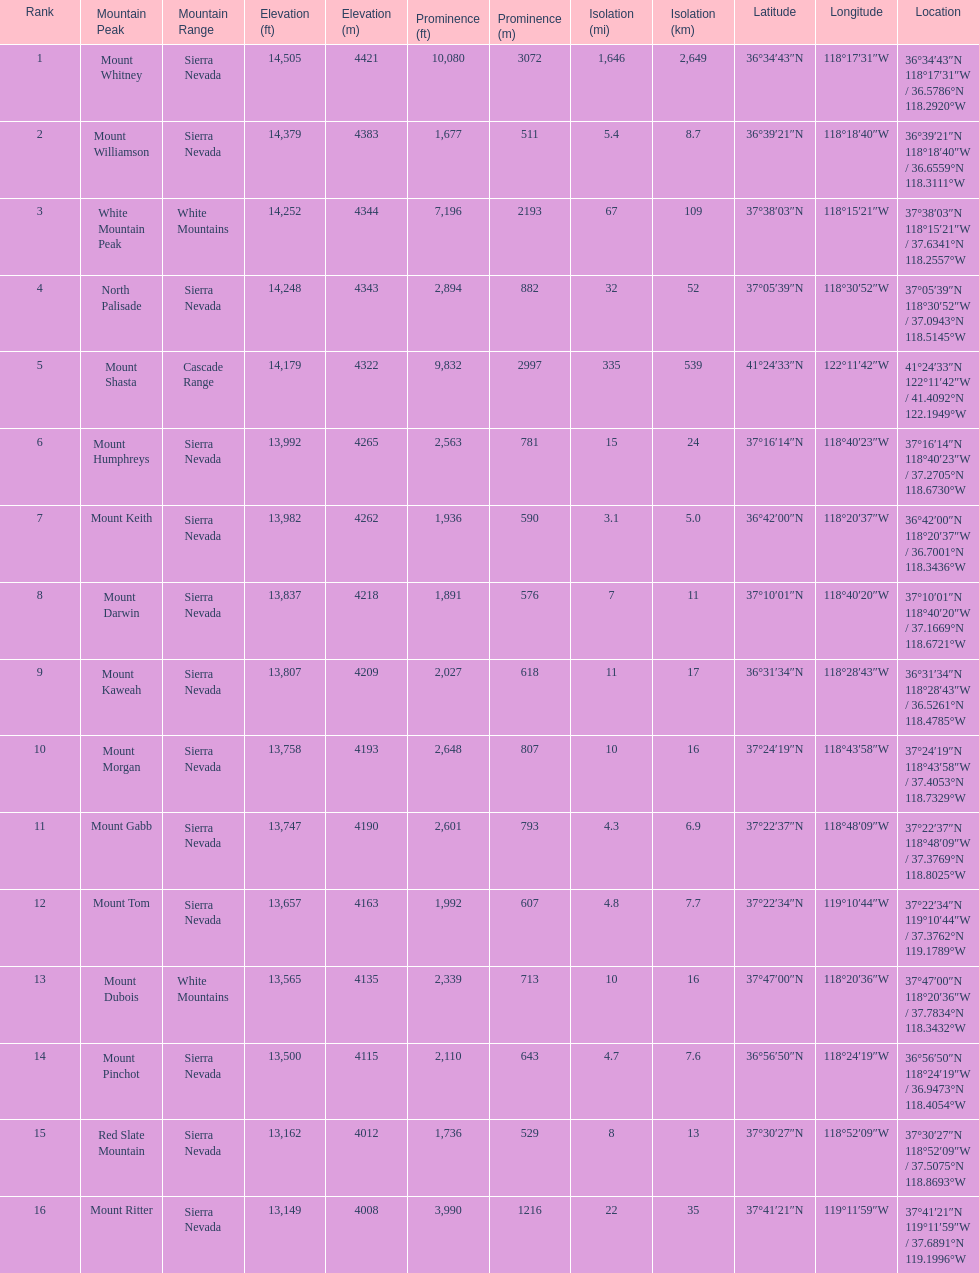Which mountain peak is in the white mountains range? White Mountain Peak. Can you parse all the data within this table? {'header': ['Rank', 'Mountain Peak', 'Mountain Range', 'Elevation (ft)', 'Elevation (m)', 'Prominence (ft)', 'Prominence (m)', 'Isolation (mi)', 'Isolation (km)', 'Latitude', 'Longitude', 'Location'], 'rows': [['1', 'Mount Whitney', 'Sierra Nevada', '14,505', '4421', '10,080', '3072', '1,646', '2,649', '36°34′43″N', '118°17′31″W\ufeff', '36°34′43″N 118°17′31″W\ufeff / \ufeff36.5786°N 118.2920°W'], ['2', 'Mount Williamson', 'Sierra Nevada', '14,379', '4383', '1,677', '511', '5.4', '8.7', '36°39′21″N', '118°18′40″W\ufeff', '36°39′21″N 118°18′40″W\ufeff / \ufeff36.6559°N 118.3111°W'], ['3', 'White Mountain Peak', 'White Mountains', '14,252', '4344', '7,196', '2193', '67', '109', '37°38′03″N', '118°15′21″W\ufeff', '37°38′03″N 118°15′21″W\ufeff / \ufeff37.6341°N 118.2557°W'], ['4', 'North Palisade', 'Sierra Nevada', '14,248', '4343', '2,894', '882', '32', '52', '37°05′39″N', '118°30′52″W\ufeff', '37°05′39″N 118°30′52″W\ufeff / \ufeff37.0943°N 118.5145°W'], ['5', 'Mount Shasta', 'Cascade Range', '14,179', '4322', '9,832', '2997', '335', '539', '41°24′33″N', '122°11′42″W\ufeff', '41°24′33″N 122°11′42″W\ufeff / \ufeff41.4092°N 122.1949°W'], ['6', 'Mount Humphreys', 'Sierra Nevada', '13,992', '4265', '2,563', '781', '15', '24', '37°16′14″N', '118°40′23″W\ufeff', '37°16′14″N 118°40′23″W\ufeff / \ufeff37.2705°N 118.6730°W'], ['7', 'Mount Keith', 'Sierra Nevada', '13,982', '4262', '1,936', '590', '3.1', '5.0', '36°42′00″N', '118°20′37″W\ufeff', '36°42′00″N 118°20′37″W\ufeff / \ufeff36.7001°N 118.3436°W'], ['8', 'Mount Darwin', 'Sierra Nevada', '13,837', '4218', '1,891', '576', '7', '11', '37°10′01″N', '118°40′20″W\ufeff', '37°10′01″N 118°40′20″W\ufeff / \ufeff37.1669°N 118.6721°W'], ['9', 'Mount Kaweah', 'Sierra Nevada', '13,807', '4209', '2,027', '618', '11', '17', '36°31′34″N', '118°28′43″W\ufeff', '36°31′34″N 118°28′43″W\ufeff / \ufeff36.5261°N 118.4785°W'], ['10', 'Mount Morgan', 'Sierra Nevada', '13,758', '4193', '2,648', '807', '10', '16', '37°24′19″N', '118°43′58″W\ufeff', '37°24′19″N 118°43′58″W\ufeff / \ufeff37.4053°N 118.7329°W'], ['11', 'Mount Gabb', 'Sierra Nevada', '13,747', '4190', '2,601', '793', '4.3', '6.9', '37°22′37″N', '118°48′09″W\ufeff', '37°22′37″N 118°48′09″W\ufeff / \ufeff37.3769°N 118.8025°W'], ['12', 'Mount Tom', 'Sierra Nevada', '13,657', '4163', '1,992', '607', '4.8', '7.7', '37°22′34″N', '119°10′44″W\ufeff', '37°22′34″N 119°10′44″W\ufeff / \ufeff37.3762°N 119.1789°W'], ['13', 'Mount Dubois', 'White Mountains', '13,565', '4135', '2,339', '713', '10', '16', '37°47′00″N', '118°20′36″W\ufeff', '37°47′00″N 118°20′36″W\ufeff / \ufeff37.7834°N 118.3432°W'], ['14', 'Mount Pinchot', 'Sierra Nevada', '13,500', '4115', '2,110', '643', '4.7', '7.6', '36°56′50″N', '118°24′19″W\ufeff', '36°56′50″N 118°24′19″W\ufeff / \ufeff36.9473°N 118.4054°W'], ['15', 'Red Slate Mountain', 'Sierra Nevada', '13,162', '4012', '1,736', '529', '8', '13', '37°30′27″N', '118°52′09″W\ufeff', '37°30′27″N 118°52′09″W\ufeff / \ufeff37.5075°N 118.8693°W'], ['16', 'Mount Ritter', 'Sierra Nevada', '13,149', '4008', '3,990', '1216', '22', '35', '37°41′21″N', '119°11′59″W\ufeff', '37°41′21″N 119°11′59″W\ufeff / \ufeff37.6891°N 119.1996°W']]} Which mountain is in the sierra nevada range? Mount Whitney. Which mountain is the only one in the cascade range? Mount Shasta. 